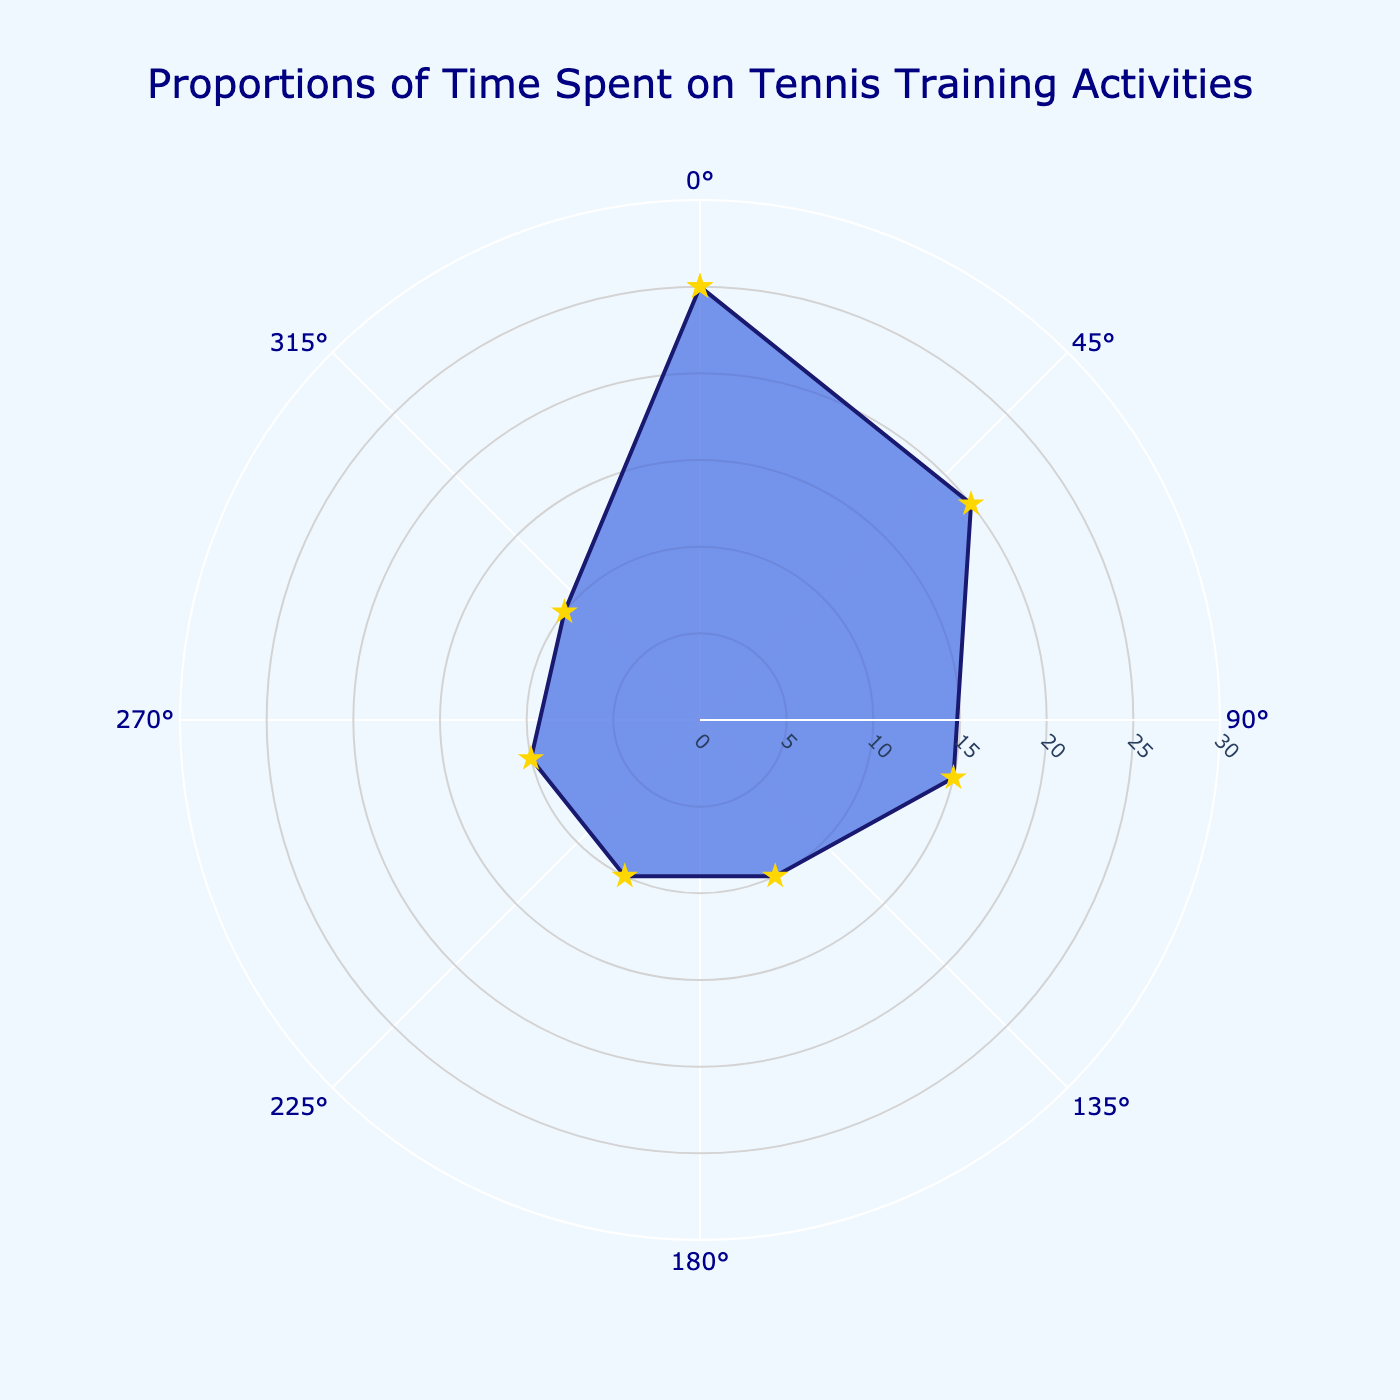What is the title of the figure? The title is typically displayed at the top of the figure. In this case, it reads "Proportions of Time Spent on Tennis Training Activities."
Answer: Proportions of Time Spent on Tennis Training Activities Which activity is allocated the most time? The activity with the largest proportion in the chart corresponds to the highest radial value. Here, "Serving" has the highest proportion of 25.
Answer: Serving What is the proportion of time spent on "Backhand Practice"? By referring to the data labels around the chart, you can see that "Backhand Practice" has a proportion of 10.
Answer: 10 How many activities have equal proportions of time spent? From the data and chart, you observe that "Forehand Practice," "Backhand Practice," "Conditioning," and "Scrimmage Matches" all have a proportion of 10 each. So, four activities have equal proportions.
Answer: 4 What is the total proportion of time allocated to "Volleying" and "Scrimmage Matches"? Add the proportions of "Volleying" (15) and "Scrimmage Matches" (10). 15 + 10 = 25.
Answer: 25 Which activity has the smallest proportion of time spent, excluding any ties? The smallest proportions (both 10) are for "Forehand Practice," "Backhand Practice," "Conditioning," and "Scrimmage Matches." Since there are ties, the question should consider all four.
Answer: Forehand Practice, Backhand Practice, Conditioning, Scrimmage Matches Is the time spent on "Footwork Drills" greater than the time spent on "Conditioning"? Compare the proportions for "Footwork Drills" (20) and "Conditioning" (10). 20 is greater than 10.
Answer: Yes What is the combined proportion of time spent on "Serving" and "Footwork Drills"? Add the time proportions for "Serving" (25) and "Footwork Drills" (20). 25 + 20 = 45.
Answer: 45 What's the difference in time proportion between "Serving" and "Volleying"? Subtract the proportion of "Volleying" (15) from "Serving" (25). 25 - 15 = 10.
Answer: 10 Considering the radial and angular axes, which proportion makes up at least half the circumference of the chart? The proportion half of 100% is 50%. No single activity exceeds 25%, so none make up at least half the circumference.
Answer: None 